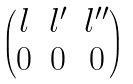<formula> <loc_0><loc_0><loc_500><loc_500>\begin{pmatrix} l & l ^ { \prime } & l ^ { \prime \prime } \\ 0 & 0 & 0 \end{pmatrix}</formula> 